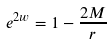Convert formula to latex. <formula><loc_0><loc_0><loc_500><loc_500>e ^ { 2 w } = 1 - \frac { 2 M } { r }</formula> 